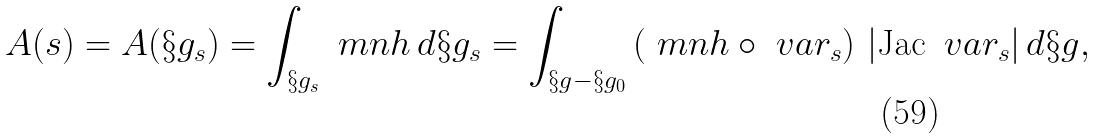<formula> <loc_0><loc_0><loc_500><loc_500>A ( s ) = A ( \S g _ { s } ) = \int _ { \S g _ { s } } \ m n h \, d \S g _ { s } = \int _ { \S g - \S g _ { 0 } } \left ( \ m n h \circ \ v a r _ { s } \right ) \, | \text {Jac} \, \ v a r _ { s } | \, d \S g ,</formula> 